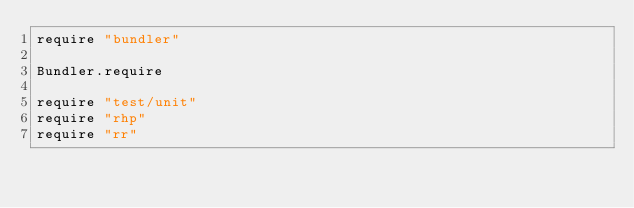<code> <loc_0><loc_0><loc_500><loc_500><_Ruby_>require "bundler"

Bundler.require

require "test/unit"
require "rhp"
require "rr"


</code> 